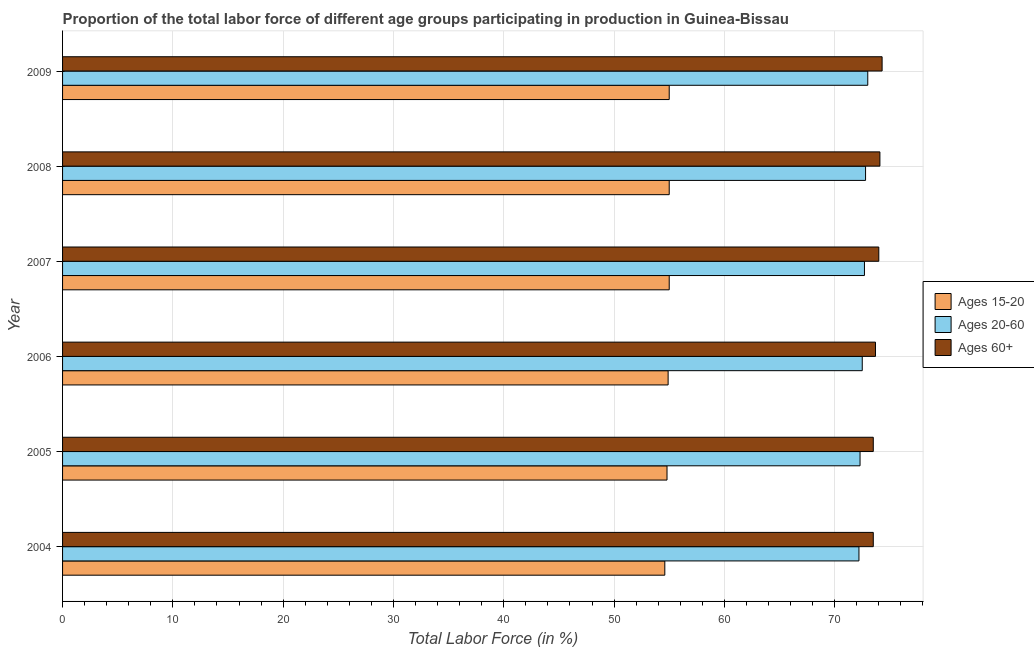How many different coloured bars are there?
Offer a terse response. 3. How many groups of bars are there?
Your response must be concise. 6. Are the number of bars per tick equal to the number of legend labels?
Your answer should be very brief. Yes. How many bars are there on the 5th tick from the bottom?
Provide a short and direct response. 3. What is the label of the 5th group of bars from the top?
Give a very brief answer. 2005. In how many cases, is the number of bars for a given year not equal to the number of legend labels?
Keep it short and to the point. 0. What is the percentage of labor force above age 60 in 2009?
Offer a terse response. 74.3. Across all years, what is the minimum percentage of labor force above age 60?
Keep it short and to the point. 73.5. What is the total percentage of labor force within the age group 15-20 in the graph?
Ensure brevity in your answer.  329.3. What is the difference between the percentage of labor force within the age group 20-60 in 2004 and that in 2009?
Make the answer very short. -0.8. What is the difference between the percentage of labor force within the age group 20-60 in 2007 and the percentage of labor force within the age group 15-20 in 2006?
Your response must be concise. 17.8. What is the average percentage of labor force above age 60 per year?
Your response must be concise. 73.85. In the year 2009, what is the difference between the percentage of labor force above age 60 and percentage of labor force within the age group 20-60?
Provide a succinct answer. 1.3. In how many years, is the percentage of labor force within the age group 20-60 greater than 4 %?
Make the answer very short. 6. Is the difference between the percentage of labor force within the age group 15-20 in 2007 and 2009 greater than the difference between the percentage of labor force within the age group 20-60 in 2007 and 2009?
Your answer should be compact. Yes. What is the difference between the highest and the lowest percentage of labor force above age 60?
Offer a terse response. 0.8. Is the sum of the percentage of labor force within the age group 20-60 in 2004 and 2005 greater than the maximum percentage of labor force above age 60 across all years?
Offer a very short reply. Yes. What does the 2nd bar from the top in 2006 represents?
Give a very brief answer. Ages 20-60. What does the 3rd bar from the bottom in 2008 represents?
Your response must be concise. Ages 60+. Is it the case that in every year, the sum of the percentage of labor force within the age group 15-20 and percentage of labor force within the age group 20-60 is greater than the percentage of labor force above age 60?
Offer a very short reply. Yes. How many years are there in the graph?
Make the answer very short. 6. Does the graph contain grids?
Offer a very short reply. Yes. Where does the legend appear in the graph?
Provide a succinct answer. Center right. How are the legend labels stacked?
Offer a very short reply. Vertical. What is the title of the graph?
Provide a succinct answer. Proportion of the total labor force of different age groups participating in production in Guinea-Bissau. What is the label or title of the Y-axis?
Make the answer very short. Year. What is the Total Labor Force (in %) in Ages 15-20 in 2004?
Your answer should be very brief. 54.6. What is the Total Labor Force (in %) of Ages 20-60 in 2004?
Ensure brevity in your answer.  72.2. What is the Total Labor Force (in %) in Ages 60+ in 2004?
Provide a succinct answer. 73.5. What is the Total Labor Force (in %) of Ages 15-20 in 2005?
Ensure brevity in your answer.  54.8. What is the Total Labor Force (in %) of Ages 20-60 in 2005?
Your answer should be very brief. 72.3. What is the Total Labor Force (in %) of Ages 60+ in 2005?
Provide a short and direct response. 73.5. What is the Total Labor Force (in %) in Ages 15-20 in 2006?
Your response must be concise. 54.9. What is the Total Labor Force (in %) in Ages 20-60 in 2006?
Keep it short and to the point. 72.5. What is the Total Labor Force (in %) of Ages 60+ in 2006?
Your response must be concise. 73.7. What is the Total Labor Force (in %) in Ages 15-20 in 2007?
Offer a terse response. 55. What is the Total Labor Force (in %) in Ages 20-60 in 2007?
Provide a succinct answer. 72.7. What is the Total Labor Force (in %) of Ages 60+ in 2007?
Keep it short and to the point. 74. What is the Total Labor Force (in %) of Ages 15-20 in 2008?
Provide a short and direct response. 55. What is the Total Labor Force (in %) in Ages 20-60 in 2008?
Ensure brevity in your answer.  72.8. What is the Total Labor Force (in %) in Ages 60+ in 2008?
Keep it short and to the point. 74.1. What is the Total Labor Force (in %) of Ages 20-60 in 2009?
Provide a short and direct response. 73. What is the Total Labor Force (in %) of Ages 60+ in 2009?
Make the answer very short. 74.3. Across all years, what is the maximum Total Labor Force (in %) of Ages 15-20?
Make the answer very short. 55. Across all years, what is the maximum Total Labor Force (in %) in Ages 60+?
Give a very brief answer. 74.3. Across all years, what is the minimum Total Labor Force (in %) of Ages 15-20?
Make the answer very short. 54.6. Across all years, what is the minimum Total Labor Force (in %) in Ages 20-60?
Give a very brief answer. 72.2. Across all years, what is the minimum Total Labor Force (in %) of Ages 60+?
Offer a very short reply. 73.5. What is the total Total Labor Force (in %) of Ages 15-20 in the graph?
Ensure brevity in your answer.  329.3. What is the total Total Labor Force (in %) of Ages 20-60 in the graph?
Provide a succinct answer. 435.5. What is the total Total Labor Force (in %) of Ages 60+ in the graph?
Keep it short and to the point. 443.1. What is the difference between the Total Labor Force (in %) of Ages 15-20 in 2004 and that in 2005?
Offer a terse response. -0.2. What is the difference between the Total Labor Force (in %) of Ages 60+ in 2004 and that in 2005?
Give a very brief answer. 0. What is the difference between the Total Labor Force (in %) of Ages 20-60 in 2004 and that in 2006?
Ensure brevity in your answer.  -0.3. What is the difference between the Total Labor Force (in %) of Ages 60+ in 2004 and that in 2006?
Offer a very short reply. -0.2. What is the difference between the Total Labor Force (in %) in Ages 15-20 in 2004 and that in 2007?
Offer a very short reply. -0.4. What is the difference between the Total Labor Force (in %) of Ages 20-60 in 2004 and that in 2007?
Your response must be concise. -0.5. What is the difference between the Total Labor Force (in %) of Ages 15-20 in 2004 and that in 2008?
Offer a terse response. -0.4. What is the difference between the Total Labor Force (in %) of Ages 60+ in 2004 and that in 2008?
Your answer should be very brief. -0.6. What is the difference between the Total Labor Force (in %) in Ages 60+ in 2004 and that in 2009?
Your response must be concise. -0.8. What is the difference between the Total Labor Force (in %) in Ages 15-20 in 2005 and that in 2006?
Offer a very short reply. -0.1. What is the difference between the Total Labor Force (in %) of Ages 20-60 in 2005 and that in 2007?
Offer a terse response. -0.4. What is the difference between the Total Labor Force (in %) in Ages 60+ in 2005 and that in 2007?
Offer a very short reply. -0.5. What is the difference between the Total Labor Force (in %) in Ages 60+ in 2005 and that in 2008?
Give a very brief answer. -0.6. What is the difference between the Total Labor Force (in %) in Ages 15-20 in 2005 and that in 2009?
Offer a terse response. -0.2. What is the difference between the Total Labor Force (in %) in Ages 15-20 in 2006 and that in 2007?
Offer a terse response. -0.1. What is the difference between the Total Labor Force (in %) in Ages 60+ in 2006 and that in 2007?
Provide a succinct answer. -0.3. What is the difference between the Total Labor Force (in %) of Ages 15-20 in 2006 and that in 2008?
Offer a very short reply. -0.1. What is the difference between the Total Labor Force (in %) of Ages 60+ in 2006 and that in 2008?
Provide a succinct answer. -0.4. What is the difference between the Total Labor Force (in %) of Ages 15-20 in 2007 and that in 2008?
Your answer should be very brief. 0. What is the difference between the Total Labor Force (in %) in Ages 20-60 in 2007 and that in 2008?
Your answer should be very brief. -0.1. What is the difference between the Total Labor Force (in %) of Ages 15-20 in 2007 and that in 2009?
Your response must be concise. 0. What is the difference between the Total Labor Force (in %) in Ages 15-20 in 2008 and that in 2009?
Ensure brevity in your answer.  0. What is the difference between the Total Labor Force (in %) in Ages 20-60 in 2008 and that in 2009?
Ensure brevity in your answer.  -0.2. What is the difference between the Total Labor Force (in %) in Ages 60+ in 2008 and that in 2009?
Provide a succinct answer. -0.2. What is the difference between the Total Labor Force (in %) in Ages 15-20 in 2004 and the Total Labor Force (in %) in Ages 20-60 in 2005?
Offer a very short reply. -17.7. What is the difference between the Total Labor Force (in %) of Ages 15-20 in 2004 and the Total Labor Force (in %) of Ages 60+ in 2005?
Offer a very short reply. -18.9. What is the difference between the Total Labor Force (in %) in Ages 20-60 in 2004 and the Total Labor Force (in %) in Ages 60+ in 2005?
Ensure brevity in your answer.  -1.3. What is the difference between the Total Labor Force (in %) in Ages 15-20 in 2004 and the Total Labor Force (in %) in Ages 20-60 in 2006?
Provide a short and direct response. -17.9. What is the difference between the Total Labor Force (in %) of Ages 15-20 in 2004 and the Total Labor Force (in %) of Ages 60+ in 2006?
Provide a succinct answer. -19.1. What is the difference between the Total Labor Force (in %) of Ages 20-60 in 2004 and the Total Labor Force (in %) of Ages 60+ in 2006?
Offer a very short reply. -1.5. What is the difference between the Total Labor Force (in %) of Ages 15-20 in 2004 and the Total Labor Force (in %) of Ages 20-60 in 2007?
Your answer should be compact. -18.1. What is the difference between the Total Labor Force (in %) in Ages 15-20 in 2004 and the Total Labor Force (in %) in Ages 60+ in 2007?
Your answer should be compact. -19.4. What is the difference between the Total Labor Force (in %) of Ages 20-60 in 2004 and the Total Labor Force (in %) of Ages 60+ in 2007?
Your answer should be compact. -1.8. What is the difference between the Total Labor Force (in %) of Ages 15-20 in 2004 and the Total Labor Force (in %) of Ages 20-60 in 2008?
Give a very brief answer. -18.2. What is the difference between the Total Labor Force (in %) in Ages 15-20 in 2004 and the Total Labor Force (in %) in Ages 60+ in 2008?
Your answer should be very brief. -19.5. What is the difference between the Total Labor Force (in %) of Ages 15-20 in 2004 and the Total Labor Force (in %) of Ages 20-60 in 2009?
Keep it short and to the point. -18.4. What is the difference between the Total Labor Force (in %) of Ages 15-20 in 2004 and the Total Labor Force (in %) of Ages 60+ in 2009?
Your answer should be compact. -19.7. What is the difference between the Total Labor Force (in %) in Ages 20-60 in 2004 and the Total Labor Force (in %) in Ages 60+ in 2009?
Offer a terse response. -2.1. What is the difference between the Total Labor Force (in %) of Ages 15-20 in 2005 and the Total Labor Force (in %) of Ages 20-60 in 2006?
Offer a very short reply. -17.7. What is the difference between the Total Labor Force (in %) in Ages 15-20 in 2005 and the Total Labor Force (in %) in Ages 60+ in 2006?
Offer a terse response. -18.9. What is the difference between the Total Labor Force (in %) in Ages 15-20 in 2005 and the Total Labor Force (in %) in Ages 20-60 in 2007?
Make the answer very short. -17.9. What is the difference between the Total Labor Force (in %) of Ages 15-20 in 2005 and the Total Labor Force (in %) of Ages 60+ in 2007?
Offer a very short reply. -19.2. What is the difference between the Total Labor Force (in %) in Ages 20-60 in 2005 and the Total Labor Force (in %) in Ages 60+ in 2007?
Your answer should be very brief. -1.7. What is the difference between the Total Labor Force (in %) of Ages 15-20 in 2005 and the Total Labor Force (in %) of Ages 60+ in 2008?
Your answer should be very brief. -19.3. What is the difference between the Total Labor Force (in %) in Ages 15-20 in 2005 and the Total Labor Force (in %) in Ages 20-60 in 2009?
Your answer should be very brief. -18.2. What is the difference between the Total Labor Force (in %) of Ages 15-20 in 2005 and the Total Labor Force (in %) of Ages 60+ in 2009?
Keep it short and to the point. -19.5. What is the difference between the Total Labor Force (in %) in Ages 20-60 in 2005 and the Total Labor Force (in %) in Ages 60+ in 2009?
Your response must be concise. -2. What is the difference between the Total Labor Force (in %) in Ages 15-20 in 2006 and the Total Labor Force (in %) in Ages 20-60 in 2007?
Offer a terse response. -17.8. What is the difference between the Total Labor Force (in %) of Ages 15-20 in 2006 and the Total Labor Force (in %) of Ages 60+ in 2007?
Keep it short and to the point. -19.1. What is the difference between the Total Labor Force (in %) in Ages 20-60 in 2006 and the Total Labor Force (in %) in Ages 60+ in 2007?
Offer a terse response. -1.5. What is the difference between the Total Labor Force (in %) in Ages 15-20 in 2006 and the Total Labor Force (in %) in Ages 20-60 in 2008?
Offer a terse response. -17.9. What is the difference between the Total Labor Force (in %) of Ages 15-20 in 2006 and the Total Labor Force (in %) of Ages 60+ in 2008?
Your answer should be compact. -19.2. What is the difference between the Total Labor Force (in %) in Ages 15-20 in 2006 and the Total Labor Force (in %) in Ages 20-60 in 2009?
Your response must be concise. -18.1. What is the difference between the Total Labor Force (in %) in Ages 15-20 in 2006 and the Total Labor Force (in %) in Ages 60+ in 2009?
Provide a short and direct response. -19.4. What is the difference between the Total Labor Force (in %) in Ages 15-20 in 2007 and the Total Labor Force (in %) in Ages 20-60 in 2008?
Your answer should be very brief. -17.8. What is the difference between the Total Labor Force (in %) in Ages 15-20 in 2007 and the Total Labor Force (in %) in Ages 60+ in 2008?
Your answer should be compact. -19.1. What is the difference between the Total Labor Force (in %) in Ages 15-20 in 2007 and the Total Labor Force (in %) in Ages 20-60 in 2009?
Your answer should be compact. -18. What is the difference between the Total Labor Force (in %) in Ages 15-20 in 2007 and the Total Labor Force (in %) in Ages 60+ in 2009?
Give a very brief answer. -19.3. What is the difference between the Total Labor Force (in %) of Ages 15-20 in 2008 and the Total Labor Force (in %) of Ages 20-60 in 2009?
Provide a short and direct response. -18. What is the difference between the Total Labor Force (in %) in Ages 15-20 in 2008 and the Total Labor Force (in %) in Ages 60+ in 2009?
Keep it short and to the point. -19.3. What is the difference between the Total Labor Force (in %) of Ages 20-60 in 2008 and the Total Labor Force (in %) of Ages 60+ in 2009?
Your response must be concise. -1.5. What is the average Total Labor Force (in %) in Ages 15-20 per year?
Your answer should be compact. 54.88. What is the average Total Labor Force (in %) in Ages 20-60 per year?
Keep it short and to the point. 72.58. What is the average Total Labor Force (in %) of Ages 60+ per year?
Your response must be concise. 73.85. In the year 2004, what is the difference between the Total Labor Force (in %) of Ages 15-20 and Total Labor Force (in %) of Ages 20-60?
Your answer should be very brief. -17.6. In the year 2004, what is the difference between the Total Labor Force (in %) in Ages 15-20 and Total Labor Force (in %) in Ages 60+?
Provide a succinct answer. -18.9. In the year 2005, what is the difference between the Total Labor Force (in %) in Ages 15-20 and Total Labor Force (in %) in Ages 20-60?
Keep it short and to the point. -17.5. In the year 2005, what is the difference between the Total Labor Force (in %) of Ages 15-20 and Total Labor Force (in %) of Ages 60+?
Make the answer very short. -18.7. In the year 2006, what is the difference between the Total Labor Force (in %) in Ages 15-20 and Total Labor Force (in %) in Ages 20-60?
Offer a terse response. -17.6. In the year 2006, what is the difference between the Total Labor Force (in %) in Ages 15-20 and Total Labor Force (in %) in Ages 60+?
Make the answer very short. -18.8. In the year 2006, what is the difference between the Total Labor Force (in %) of Ages 20-60 and Total Labor Force (in %) of Ages 60+?
Provide a succinct answer. -1.2. In the year 2007, what is the difference between the Total Labor Force (in %) in Ages 15-20 and Total Labor Force (in %) in Ages 20-60?
Keep it short and to the point. -17.7. In the year 2007, what is the difference between the Total Labor Force (in %) in Ages 20-60 and Total Labor Force (in %) in Ages 60+?
Give a very brief answer. -1.3. In the year 2008, what is the difference between the Total Labor Force (in %) of Ages 15-20 and Total Labor Force (in %) of Ages 20-60?
Provide a succinct answer. -17.8. In the year 2008, what is the difference between the Total Labor Force (in %) of Ages 15-20 and Total Labor Force (in %) of Ages 60+?
Provide a short and direct response. -19.1. In the year 2008, what is the difference between the Total Labor Force (in %) of Ages 20-60 and Total Labor Force (in %) of Ages 60+?
Your answer should be compact. -1.3. In the year 2009, what is the difference between the Total Labor Force (in %) in Ages 15-20 and Total Labor Force (in %) in Ages 60+?
Your response must be concise. -19.3. What is the ratio of the Total Labor Force (in %) of Ages 60+ in 2004 to that in 2005?
Provide a short and direct response. 1. What is the ratio of the Total Labor Force (in %) of Ages 20-60 in 2004 to that in 2006?
Keep it short and to the point. 1. What is the ratio of the Total Labor Force (in %) in Ages 15-20 in 2004 to that in 2007?
Make the answer very short. 0.99. What is the ratio of the Total Labor Force (in %) in Ages 15-20 in 2004 to that in 2008?
Your answer should be very brief. 0.99. What is the ratio of the Total Labor Force (in %) of Ages 20-60 in 2004 to that in 2009?
Give a very brief answer. 0.99. What is the ratio of the Total Labor Force (in %) of Ages 60+ in 2004 to that in 2009?
Keep it short and to the point. 0.99. What is the ratio of the Total Labor Force (in %) of Ages 15-20 in 2005 to that in 2006?
Offer a very short reply. 1. What is the ratio of the Total Labor Force (in %) in Ages 20-60 in 2005 to that in 2006?
Provide a short and direct response. 1. What is the ratio of the Total Labor Force (in %) of Ages 15-20 in 2005 to that in 2007?
Give a very brief answer. 1. What is the ratio of the Total Labor Force (in %) in Ages 20-60 in 2005 to that in 2007?
Offer a very short reply. 0.99. What is the ratio of the Total Labor Force (in %) of Ages 60+ in 2005 to that in 2007?
Ensure brevity in your answer.  0.99. What is the ratio of the Total Labor Force (in %) of Ages 15-20 in 2005 to that in 2008?
Offer a very short reply. 1. What is the ratio of the Total Labor Force (in %) of Ages 20-60 in 2005 to that in 2008?
Offer a terse response. 0.99. What is the ratio of the Total Labor Force (in %) in Ages 60+ in 2005 to that in 2008?
Ensure brevity in your answer.  0.99. What is the ratio of the Total Labor Force (in %) of Ages 15-20 in 2005 to that in 2009?
Give a very brief answer. 1. What is the ratio of the Total Labor Force (in %) of Ages 15-20 in 2006 to that in 2007?
Provide a succinct answer. 1. What is the ratio of the Total Labor Force (in %) in Ages 60+ in 2006 to that in 2009?
Offer a terse response. 0.99. What is the ratio of the Total Labor Force (in %) of Ages 15-20 in 2007 to that in 2008?
Your answer should be compact. 1. What is the ratio of the Total Labor Force (in %) of Ages 60+ in 2007 to that in 2008?
Ensure brevity in your answer.  1. What is the ratio of the Total Labor Force (in %) of Ages 15-20 in 2007 to that in 2009?
Provide a succinct answer. 1. What is the ratio of the Total Labor Force (in %) of Ages 20-60 in 2007 to that in 2009?
Your answer should be compact. 1. What is the ratio of the Total Labor Force (in %) of Ages 15-20 in 2008 to that in 2009?
Your answer should be very brief. 1. What is the ratio of the Total Labor Force (in %) in Ages 20-60 in 2008 to that in 2009?
Offer a terse response. 1. What is the ratio of the Total Labor Force (in %) of Ages 60+ in 2008 to that in 2009?
Ensure brevity in your answer.  1. 